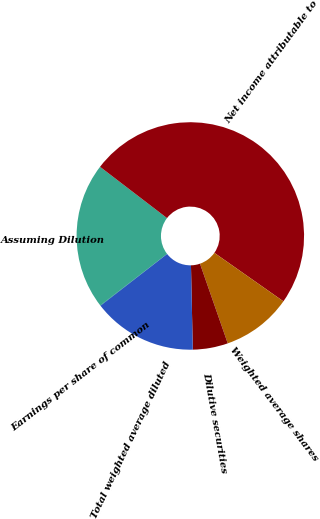<chart> <loc_0><loc_0><loc_500><loc_500><pie_chart><fcel>Assuming Dilution<fcel>Net income attributable to<fcel>Weighted average shares<fcel>Dilutive securities<fcel>Total weighted average diluted<fcel>Earnings per share of common<nl><fcel>20.85%<fcel>49.34%<fcel>9.92%<fcel>4.99%<fcel>14.84%<fcel>0.06%<nl></chart> 